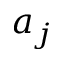Convert formula to latex. <formula><loc_0><loc_0><loc_500><loc_500>a _ { j }</formula> 